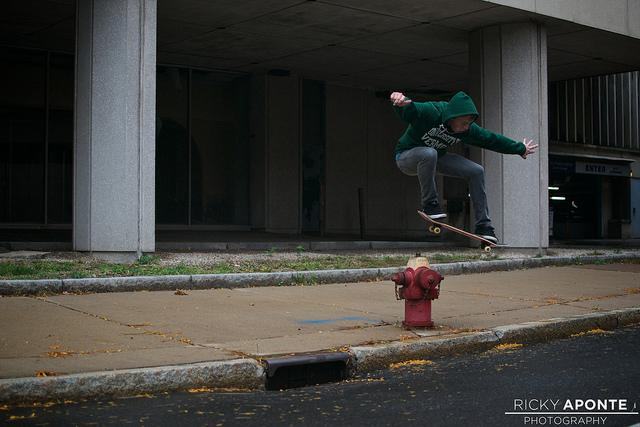Who probably took the picture? ricky aponte 